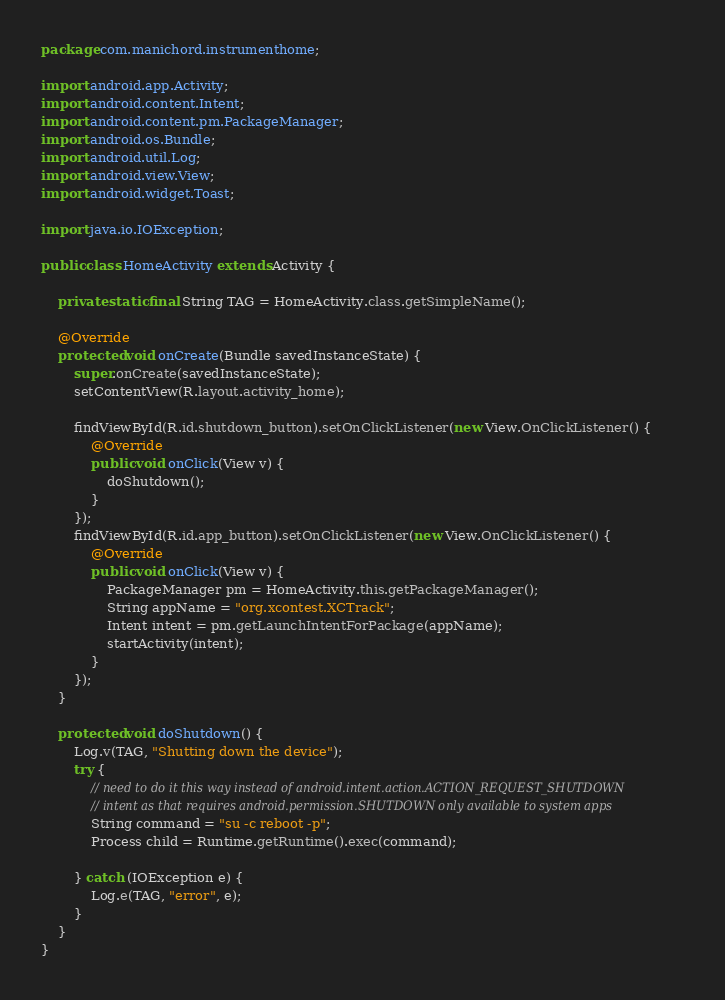<code> <loc_0><loc_0><loc_500><loc_500><_Java_>package com.manichord.instrumenthome;

import android.app.Activity;
import android.content.Intent;
import android.content.pm.PackageManager;
import android.os.Bundle;
import android.util.Log;
import android.view.View;
import android.widget.Toast;

import java.io.IOException;

public class HomeActivity extends Activity {

    private static final String TAG = HomeActivity.class.getSimpleName();

    @Override
    protected void onCreate(Bundle savedInstanceState) {
        super.onCreate(savedInstanceState);
        setContentView(R.layout.activity_home);

        findViewById(R.id.shutdown_button).setOnClickListener(new View.OnClickListener() {
            @Override
            public void onClick(View v) {
                doShutdown();
            }
        });
        findViewById(R.id.app_button).setOnClickListener(new View.OnClickListener() {
            @Override
            public void onClick(View v) {
                PackageManager pm = HomeActivity.this.getPackageManager();
                String appName = "org.xcontest.XCTrack";
                Intent intent = pm.getLaunchIntentForPackage(appName);
                startActivity(intent);
            }
        });
    }

    protected void doShutdown() {
        Log.v(TAG, "Shutting down the device");
        try {
            // need to do it this way instead of android.intent.action.ACTION_REQUEST_SHUTDOWN
            // intent as that requires android.permission.SHUTDOWN only available to system apps
            String command = "su -c reboot -p";
            Process child = Runtime.getRuntime().exec(command);

        } catch (IOException e) {
            Log.e(TAG, "error", e);
        }
    }
}
</code> 